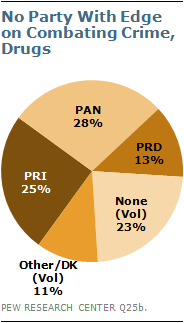Indicate a few pertinent items in this graphic. The pie chart is divided into five segments. 